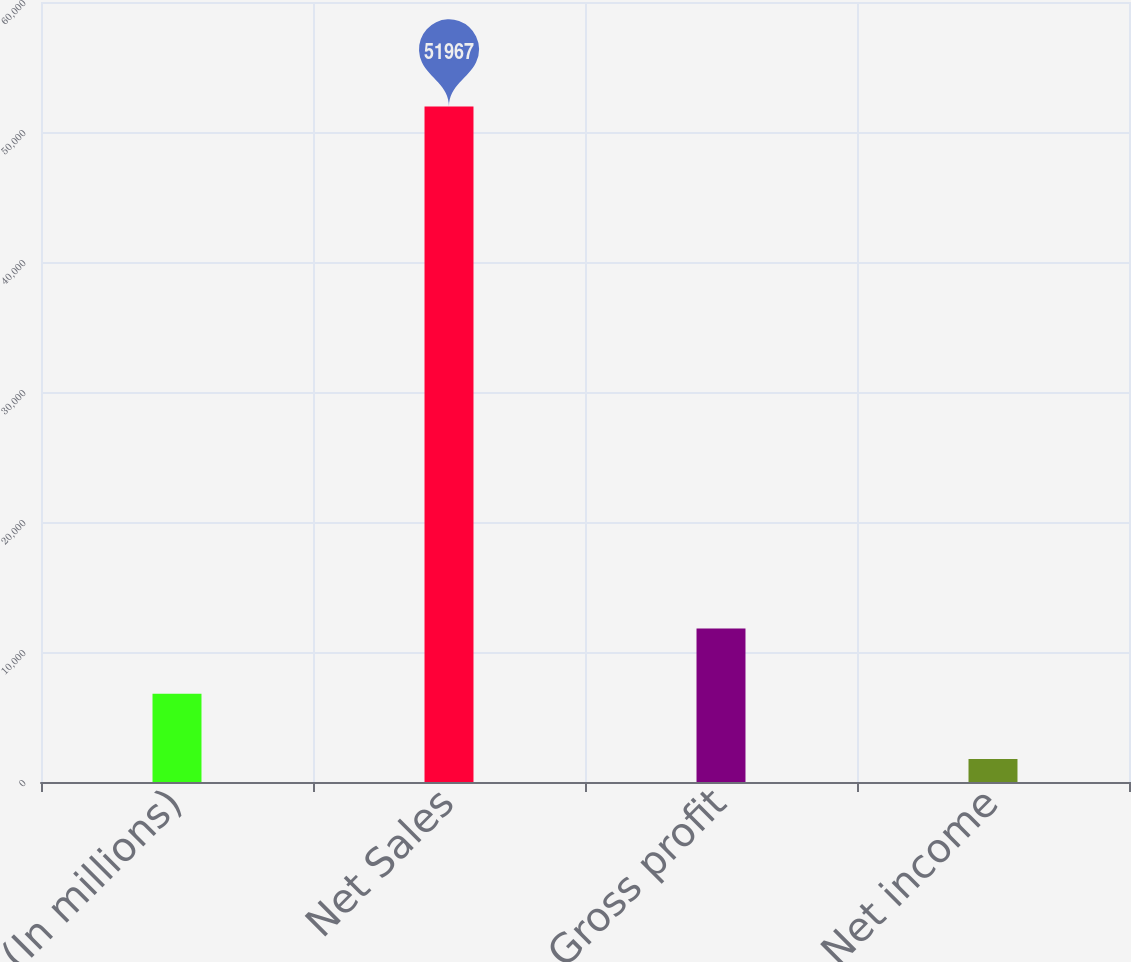<chart> <loc_0><loc_0><loc_500><loc_500><bar_chart><fcel>(In millions)<fcel>Net Sales<fcel>Gross profit<fcel>Net income<nl><fcel>6782.5<fcel>51967<fcel>11803<fcel>1762<nl></chart> 